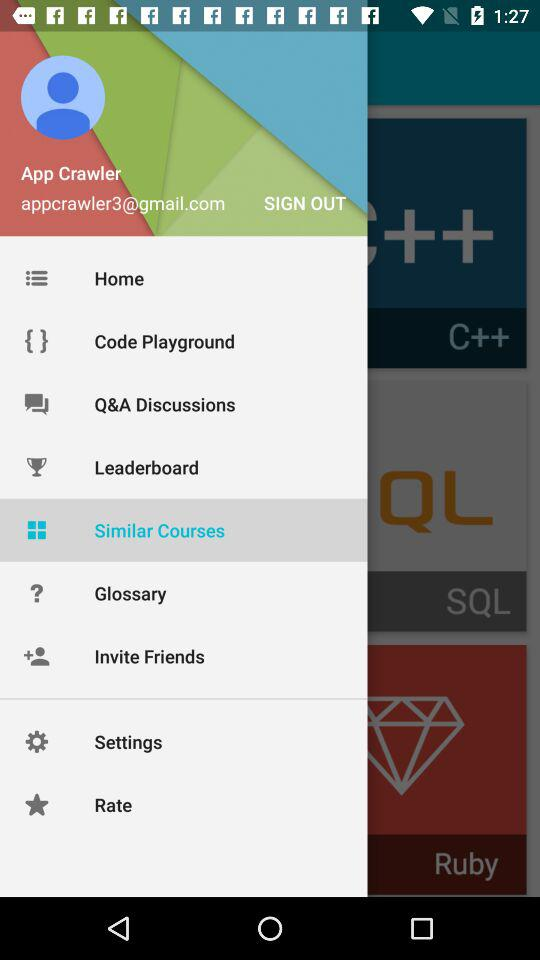What is the user name? The user name is App Crawler. 